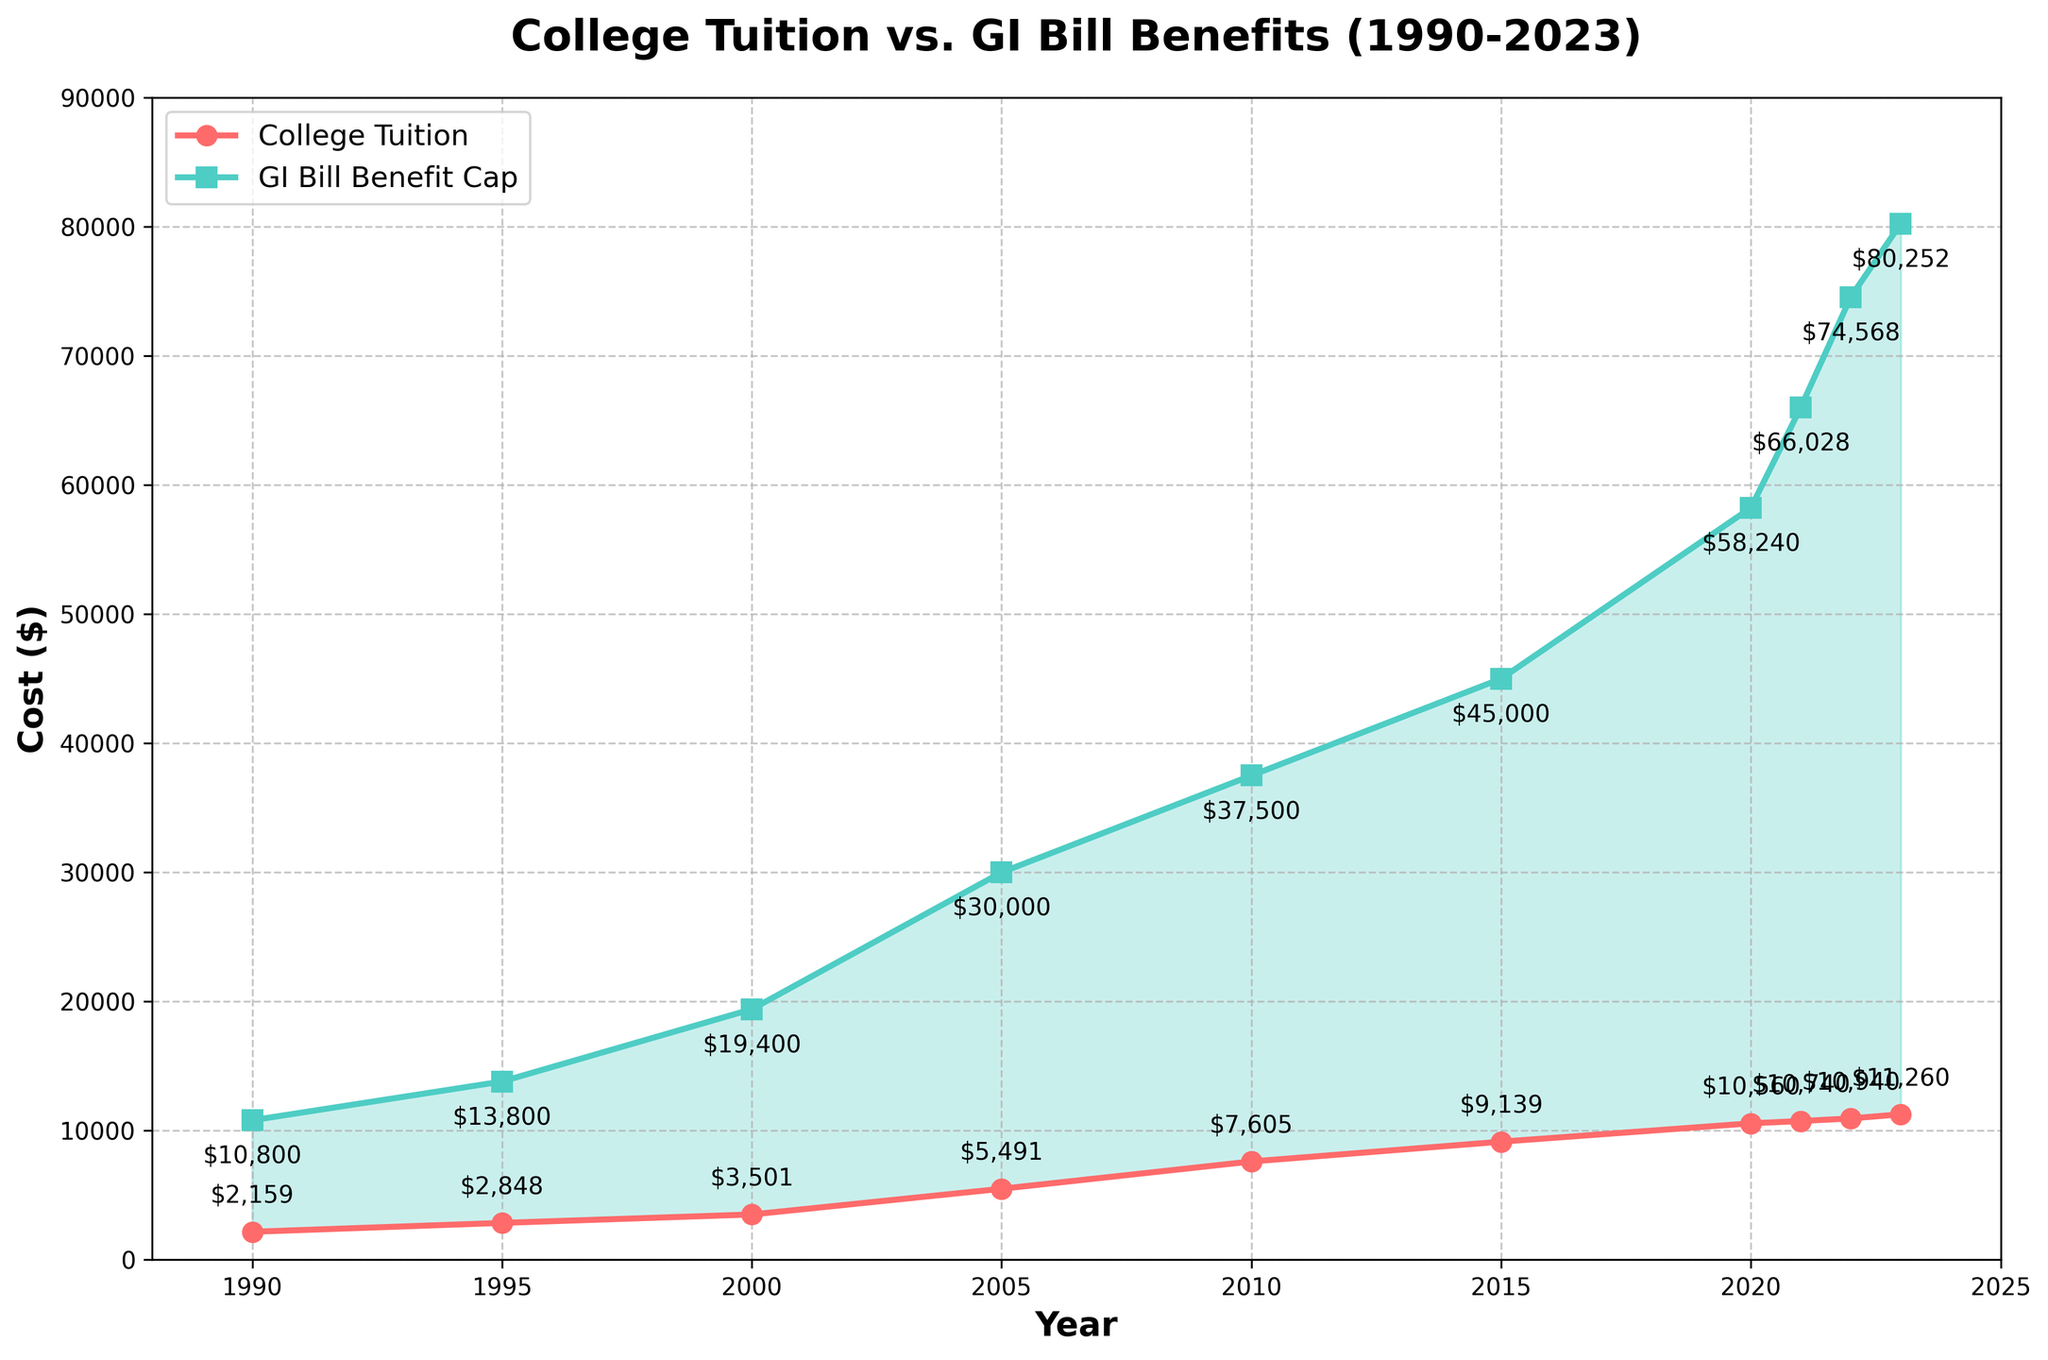How much did the average annual college tuition cost increase from 1990 to 2023? To determine the increase, subtract the 1990 tuition cost from the 2023 tuition cost: $11,260 - $2,159 = $9,101.
Answer: $9,101 In what year did the GI Bill Annual Benefit Cap first exceed $50,000? Looking at the plotted data, the GI Bill Annual Benefit Cap first exceeds $50,000 in the year 2020 when it reaches $58,240.
Answer: 2020 By how much did the GI Bill Annual Benefit Cap increase between 2000 and 2005? Subtract the 2000 benefit cap from the 2005 benefit cap: $30,000 - $19,400 = $10,600.
Answer: $10,600 Which year shows the smallest gap between the average annual college tuition and the GI Bill Annual Benefit Cap? Visually inspecting the plot, the year with the smallest gap is 1990, where the difference is $10,800 - $2,159 = $8,641.
Answer: 1990 From 1990 to 2023, which grew faster: average annual college tuition or the GI Bill Annual Benefit Cap? Calculate the percentage growth for both:
Tuition: (($11,260 - $2,159) / $2,159) * 100 ≈ 421.6%
GI Bill: (($80,252 - $10,800) / $10,800) * 100 ≈ 643.1%
The GI Bill Annual Benefit Cap grew faster.
Answer: GI Bill Annual Benefit Cap Comparing 2000 and 2010, how much more was the GI Bill Benefit Cap compared to the average annual college tuition in each year? 2000: $19,400 - $3,501 = $15,899
2010: $37,500 - $7,605 = $29,895
The increase in the margin is significant.
Answer: 2010: $29,895 What visual feature indicates the years when the GI Bill Benefit Cap was higher than the average annual college tuition? The area between the GI Bill and tuition lines is shaded in green.
Answer: Green shading In which years does the average annual college tuition exceed $10,000? By looking at the plot, the average annual college tuition exceeds $10,000 starting in 2020 and continues through to 2023.
Answer: 2020-2023 How much did the average annual college tuition increase from 2015 to 2023 compared to the increase in the GI Bill Annual Benefit Cap over the same period? Tuition increase: $11,260 - $9,139 = $2,121
GI Bill increase: $80,252 - $45,000 = $35,252
The GI Bill increase is significantly higher.
Answer: GI Bill: $35,252 What is the most noticeable trend in the plotted data from 1990 to 2023? Both average college tuition and GI Bill benefits show a consistent increase, with the GI Bill Benefit Cap increasing at a faster rate.
Answer: Rising costs and benefits 